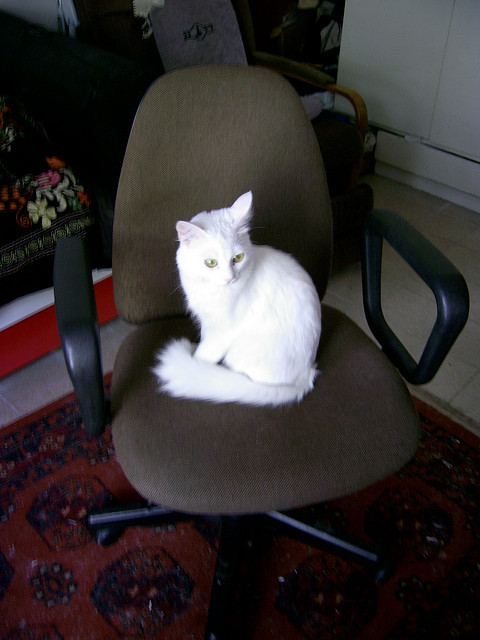<image>What material is the red chair made from? There is no red chair in the image. What breed of cat is that? I don't know the breed of the cat. It can be domestic long hair or domestic short hair. What material is the red chair made from? There is no red chair in the image. Therefore, I cannot determine the material it is made from. What breed of cat is that? I don't know which breed of cat is that. It can be 'white', 'long hair', 'domestic', 'domestic long hair', 'domestic short hair', or 'persian'. 